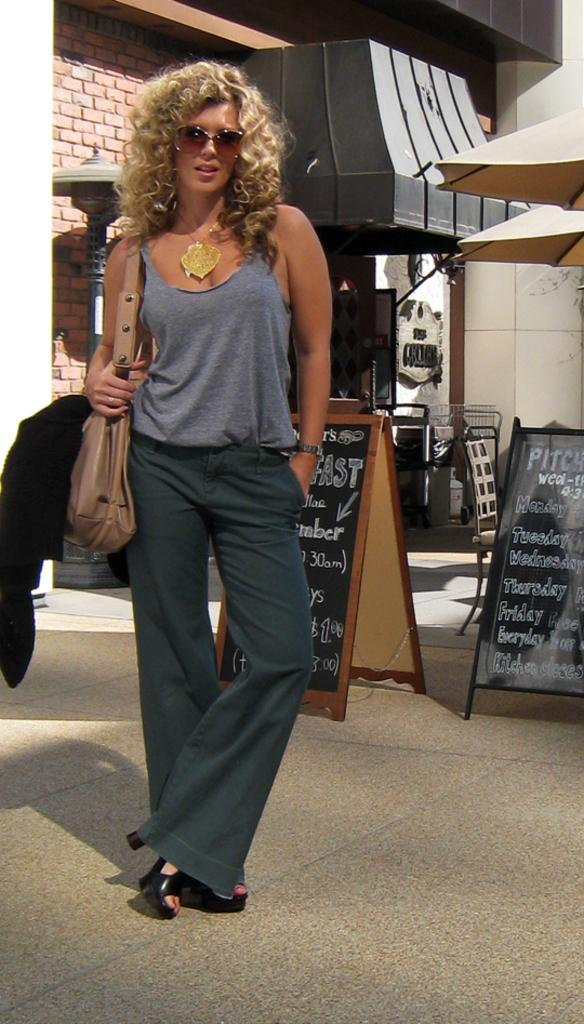Who is present in the image? There is a woman in the image. What is the woman doing in the image? The woman is standing on the floor. What is the woman holding or carrying in the image? The woman is carrying a bag. What can be seen in the background of the image? There is a wall and boards in the background of the image. How many rings is the woman wearing on her left hand in the image? There is no mention of rings in the image, so we cannot determine how many rings the woman is wearing. 